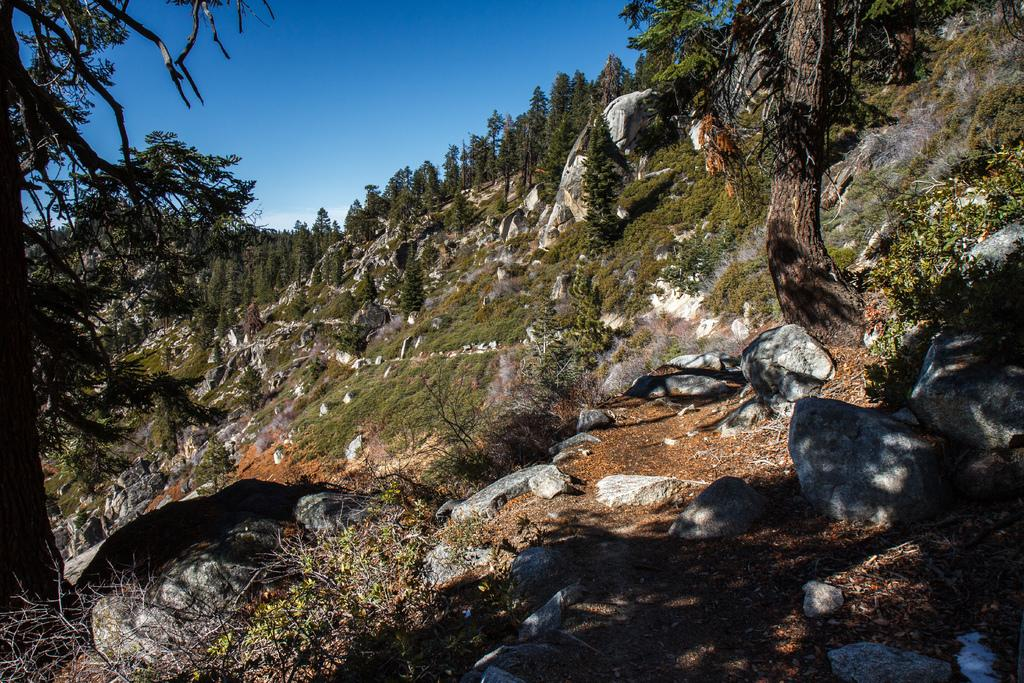What type of objects can be seen in the image? There are stones in the image. What can be seen in the background of the image? There are trees and clouds visible in the sky in the background of the image. What is the score of the baseball game happening in the image? There is no baseball game present in the image; it features stones and a background with trees and clouds. 